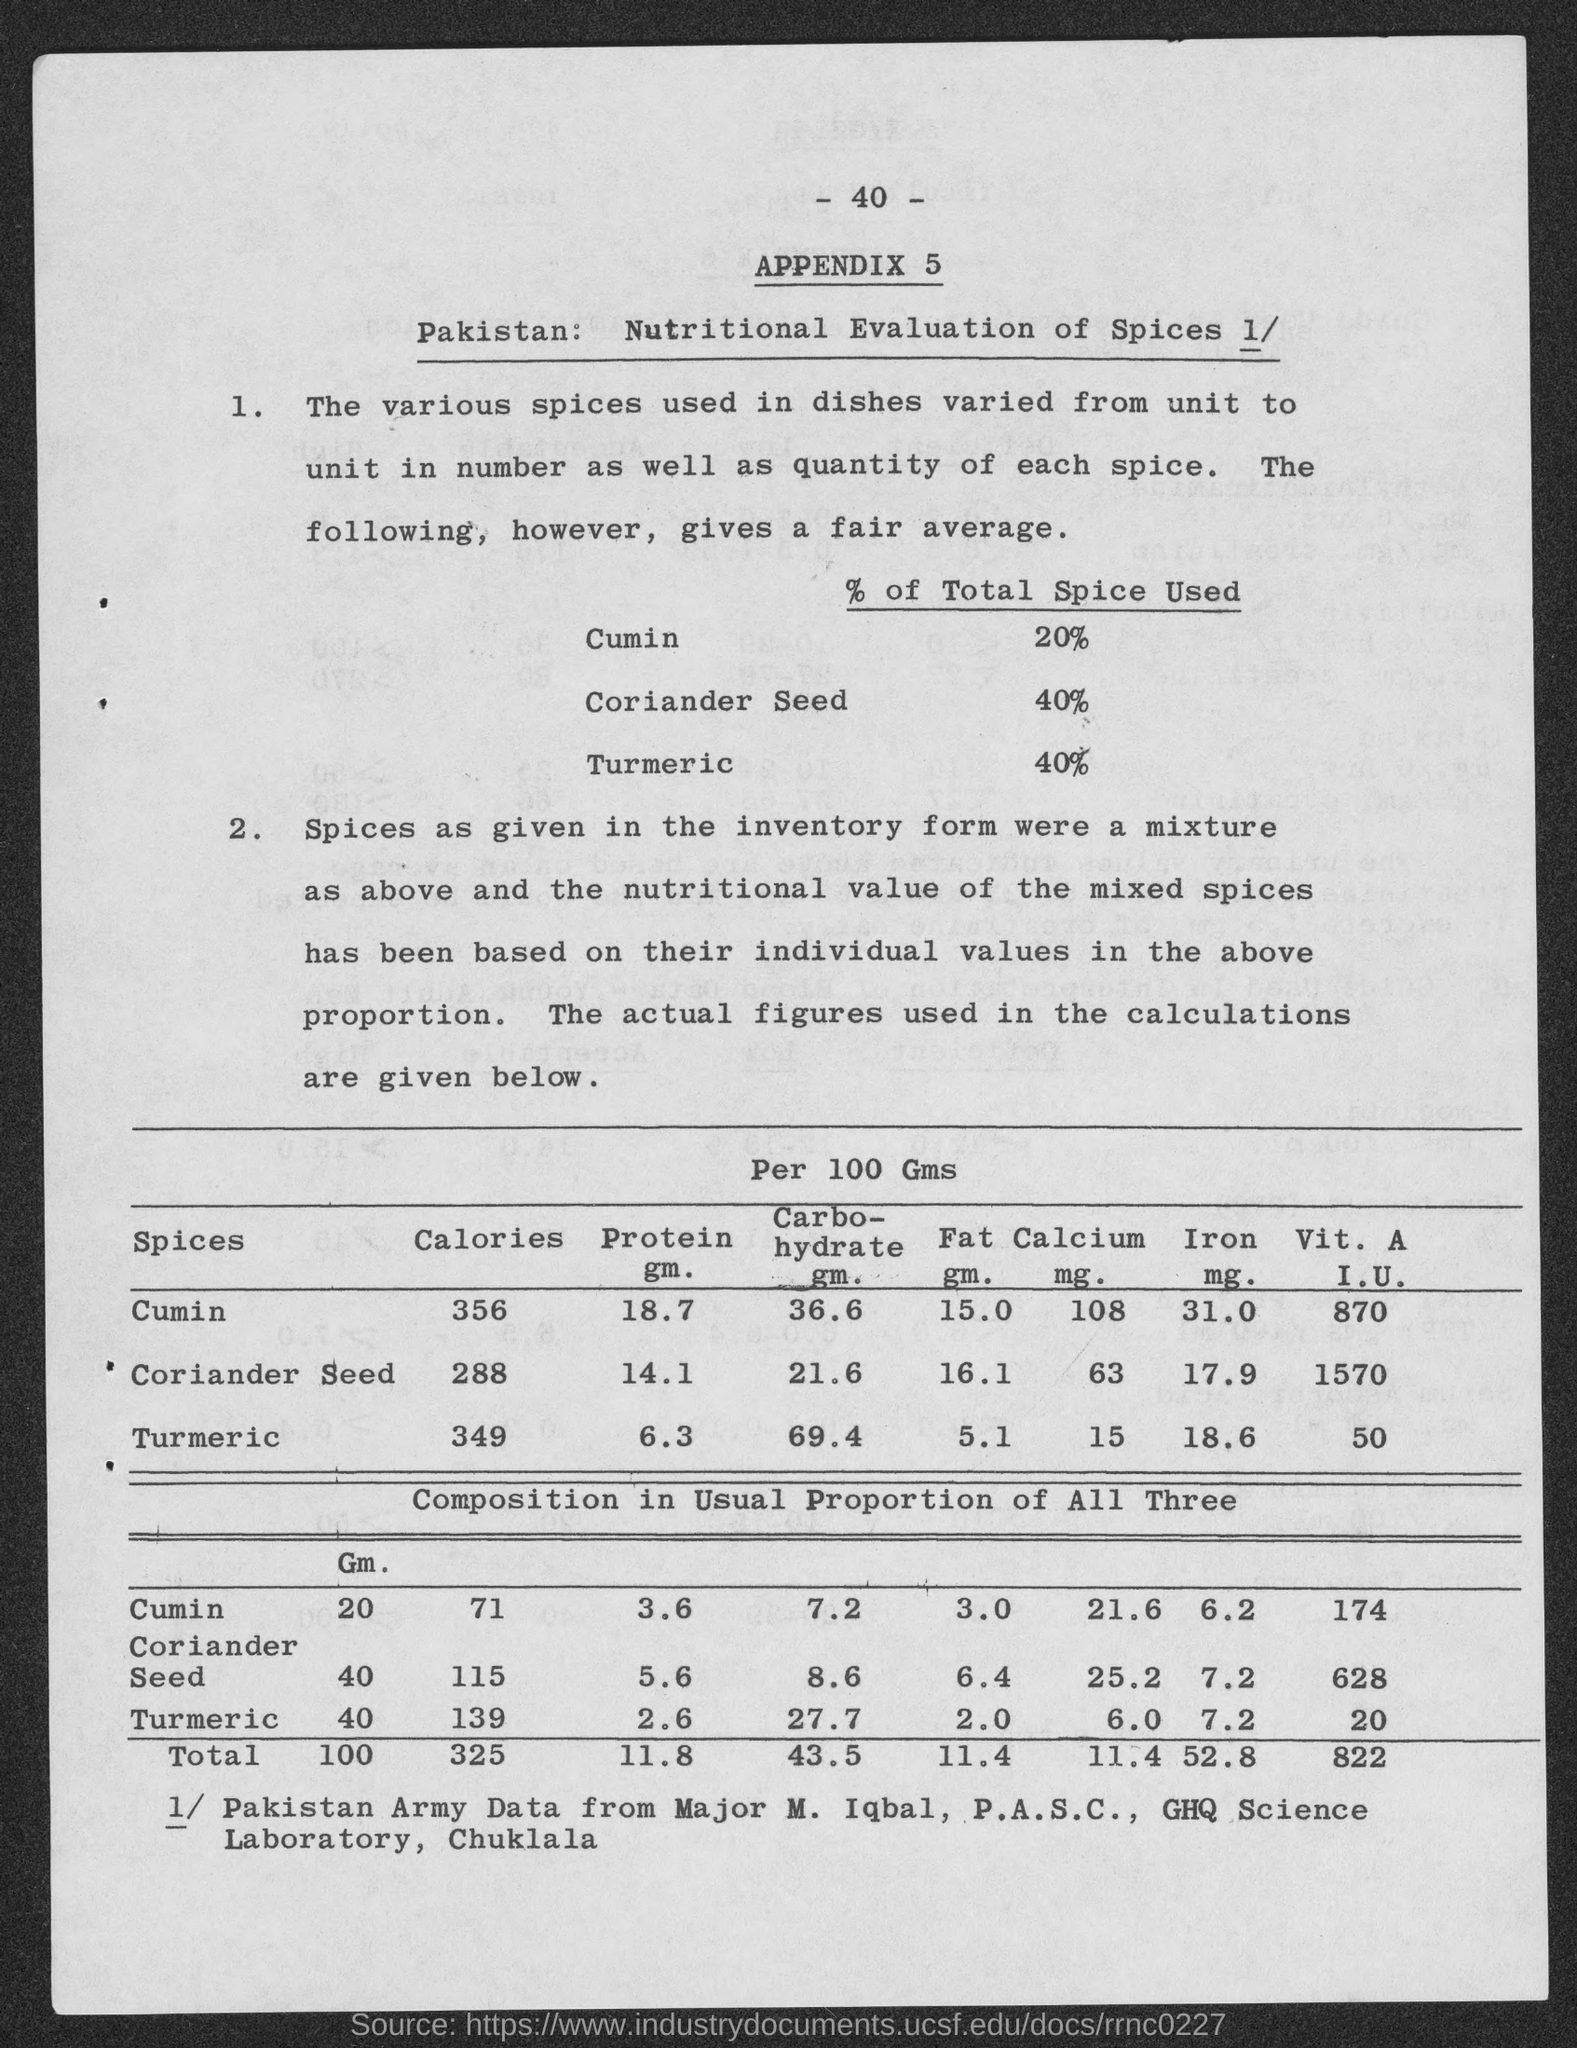Why might this document be important? This document is important because it provides a nutritional breakdown of commonly used spices in Pakistan. This kind of analysis can be critical for dietitians, health professionals, and researchers who are focused on understanding the nutritional value of local cuisines. Moreover, it could be beneficial for the agricultural sector to analyze the demand and supply of these spices based on their usage. 